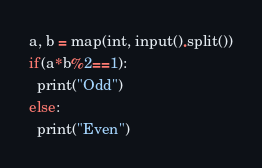<code> <loc_0><loc_0><loc_500><loc_500><_Python_>a, b = map(int, input().split())
if(a*b%2==1):
  print("Odd")
else:
  print("Even")</code> 